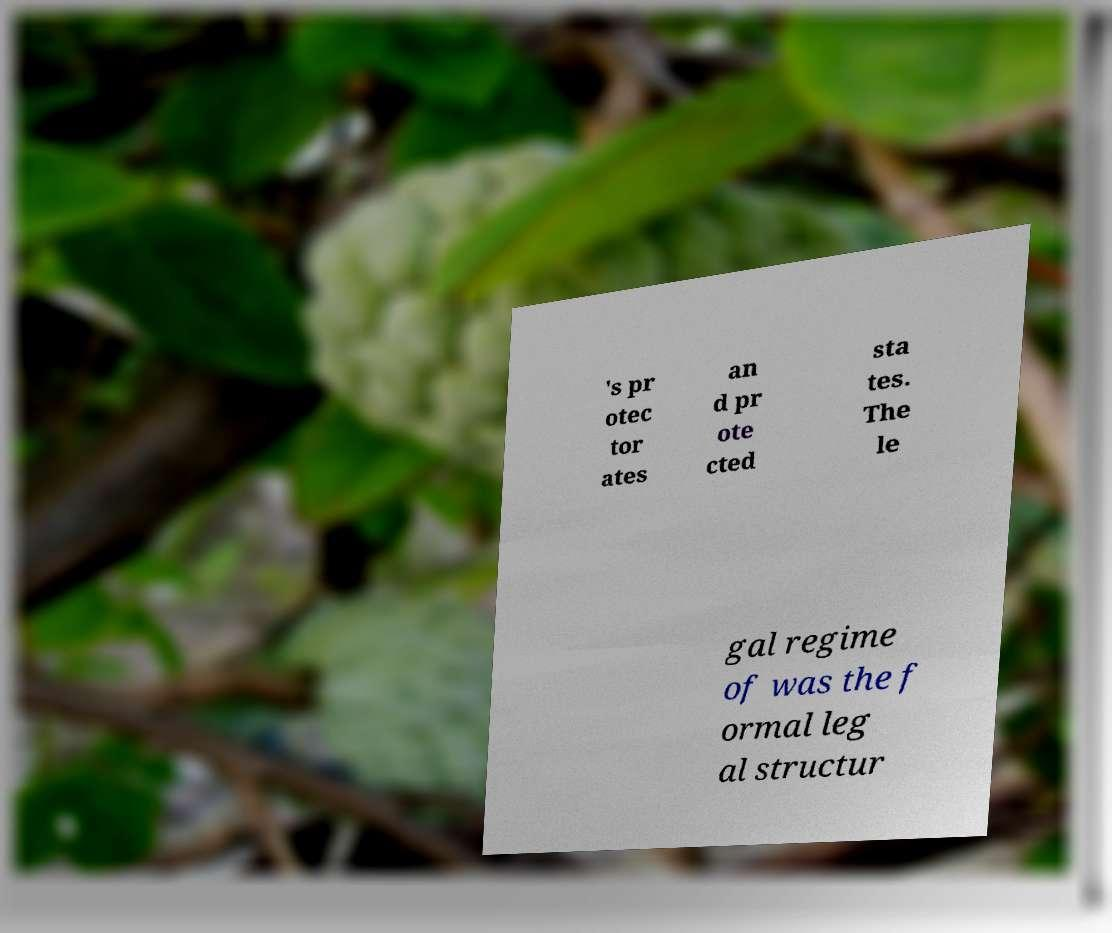Could you assist in decoding the text presented in this image and type it out clearly? 's pr otec tor ates an d pr ote cted sta tes. The le gal regime of was the f ormal leg al structur 